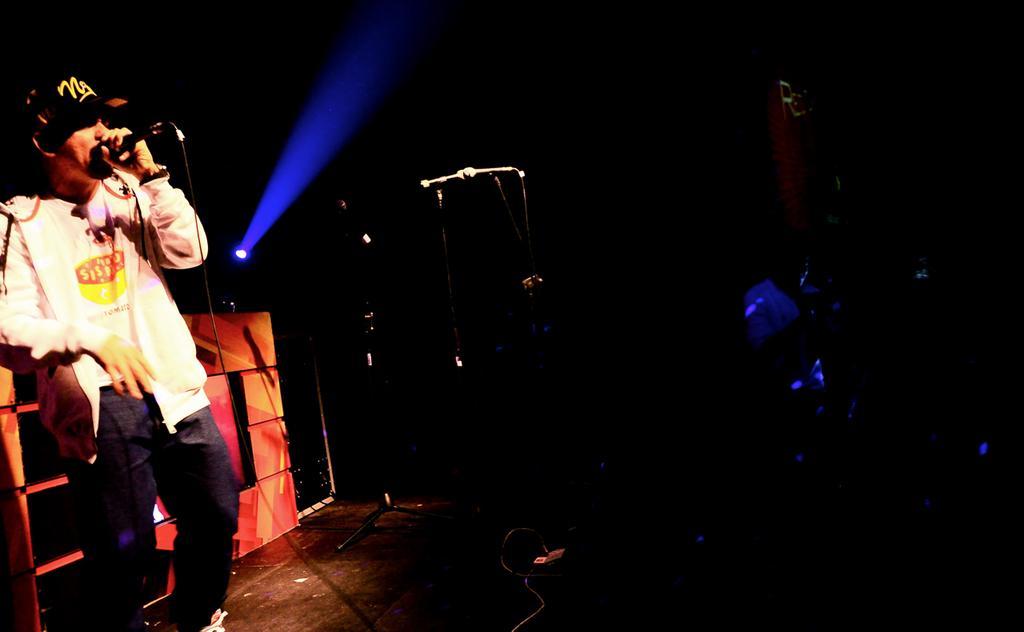In one or two sentences, can you explain what this image depicts? On the left side of the image we can see a person with the mic. In the center of the image we can see mic stand. In the background there is a light and wall. 